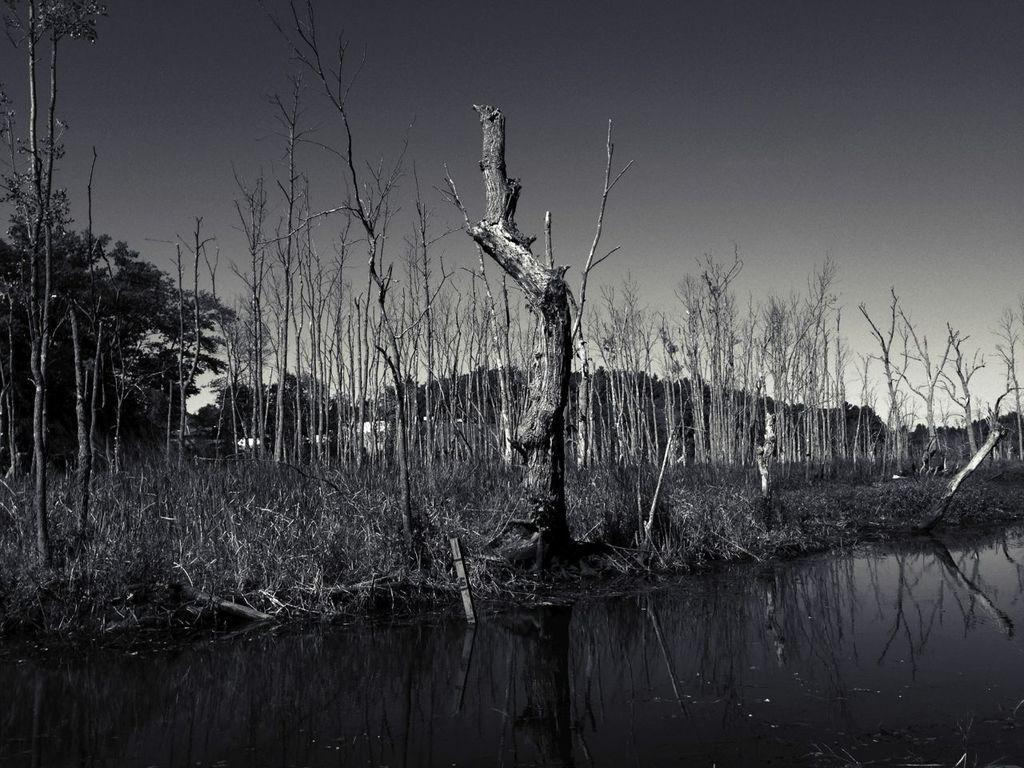What is one of the natural elements present in the image? There is water in the image. What type of vegetation can be seen in the image? There is grass and a tree trunk in the image. What can be seen in the background of the image? There are trees and the sky visible in the background of the image. What type of music can be heard coming from the tree trunk in the image? There is no music coming from the tree trunk in the image, as it is a stationary object and not capable of producing sound. 